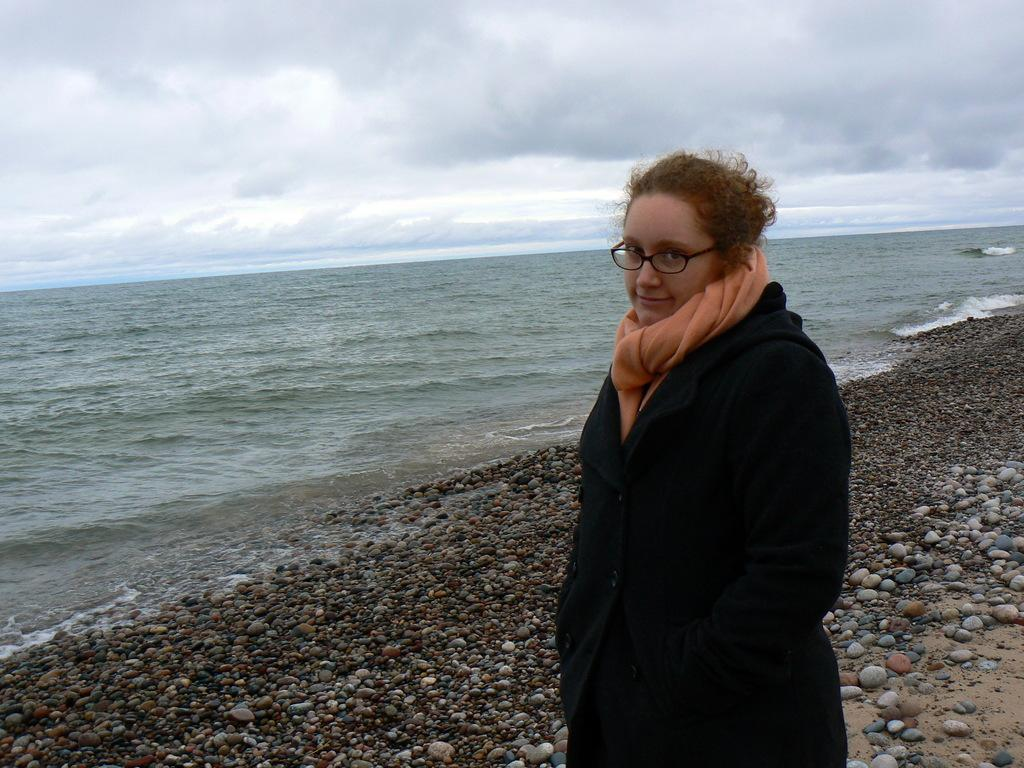Who is present in the image? There is a lady standing in the image. What can be seen in the background of the image? There are stones, the sea, and the sky visible in the background of the image. What type of glove is the lady wearing in the image? There is no glove visible in the image; the lady is not wearing any gloves. 